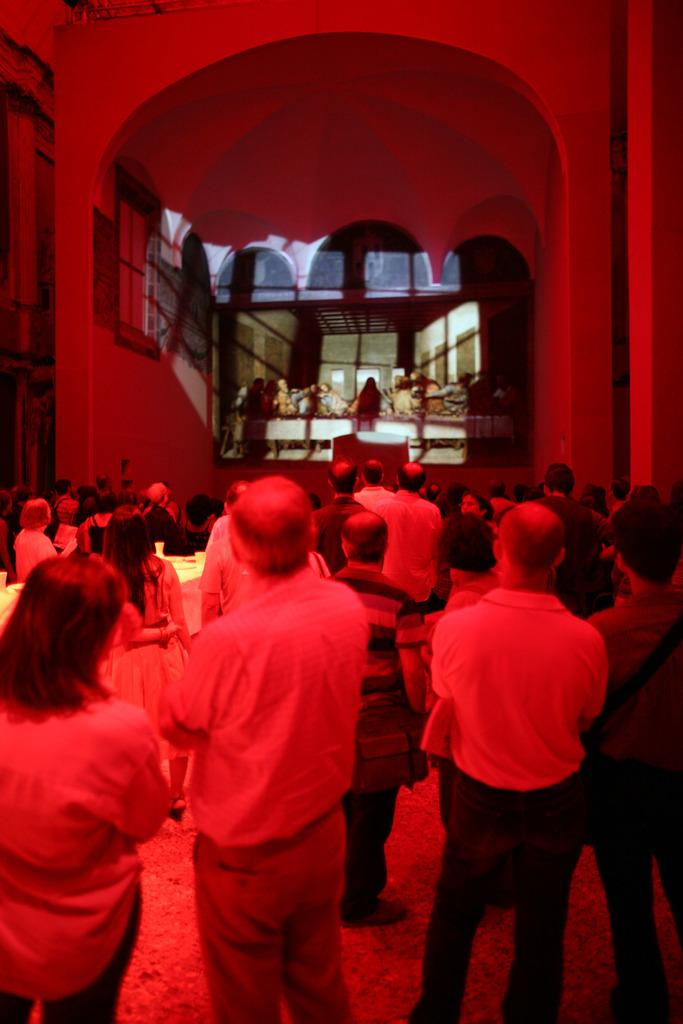What can be seen at the bottom of the image? There are people standing at the bottom of the image. What is visible in the background of the image? There is a wall in the background of the image. What object is present in the image that displays information or images? There is a screen in the image. What is located at the top of the image? There is a ceiling at the top of the image. What type of caption is written on the wall in the image? There is no caption written on the wall in the image. How many passengers are visible in the image? There is no indication of passengers in the image, as it only shows people standing at the bottom. 